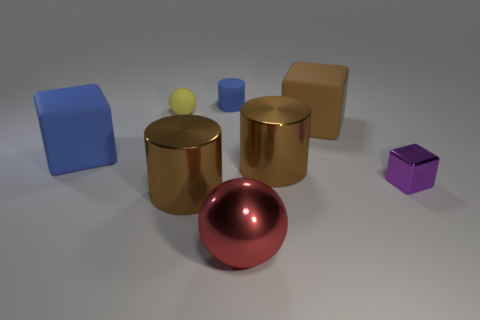What size is the brown thing that is the same material as the small sphere?
Your answer should be compact. Large. There is a large shiny thing in front of the large shiny object that is to the left of the object that is behind the yellow sphere; what shape is it?
Provide a succinct answer. Sphere. What shape is the small blue thing?
Your answer should be very brief. Cylinder. What is the color of the big block to the right of the metal sphere?
Give a very brief answer. Brown. Does the brown cylinder that is to the left of the red shiny thing have the same size as the yellow rubber thing?
Offer a terse response. No. There is a blue object that is the same shape as the purple metallic thing; what size is it?
Offer a very short reply. Large. Is the big brown rubber thing the same shape as the tiny purple thing?
Provide a short and direct response. Yes. Are there fewer brown things that are in front of the blue cube than big shiny things left of the metallic block?
Offer a terse response. Yes. There is a large brown cube; what number of cylinders are in front of it?
Your response must be concise. 2. Do the small thing to the right of the big red shiny sphere and the large rubber object to the right of the red metal sphere have the same shape?
Give a very brief answer. Yes. 